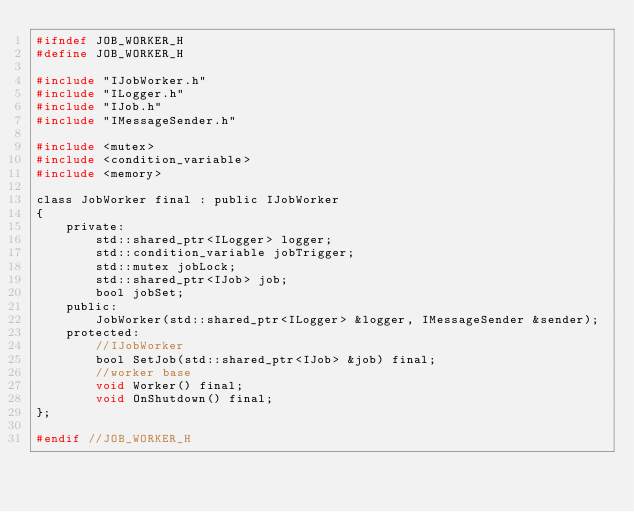Convert code to text. <code><loc_0><loc_0><loc_500><loc_500><_C_>#ifndef JOB_WORKER_H
#define JOB_WORKER_H

#include "IJobWorker.h"
#include "ILogger.h"
#include "IJob.h"
#include "IMessageSender.h"

#include <mutex>
#include <condition_variable>
#include <memory>

class JobWorker final : public IJobWorker
{
    private:
        std::shared_ptr<ILogger> logger;
        std::condition_variable jobTrigger;
        std::mutex jobLock;
        std::shared_ptr<IJob> job;
        bool jobSet;
    public:
        JobWorker(std::shared_ptr<ILogger> &logger, IMessageSender &sender);
    protected:
        //IJobWorker
        bool SetJob(std::shared_ptr<IJob> &job) final;
        //worker base
        void Worker() final;
        void OnShutdown() final;
};

#endif //JOB_WORKER_H

</code> 